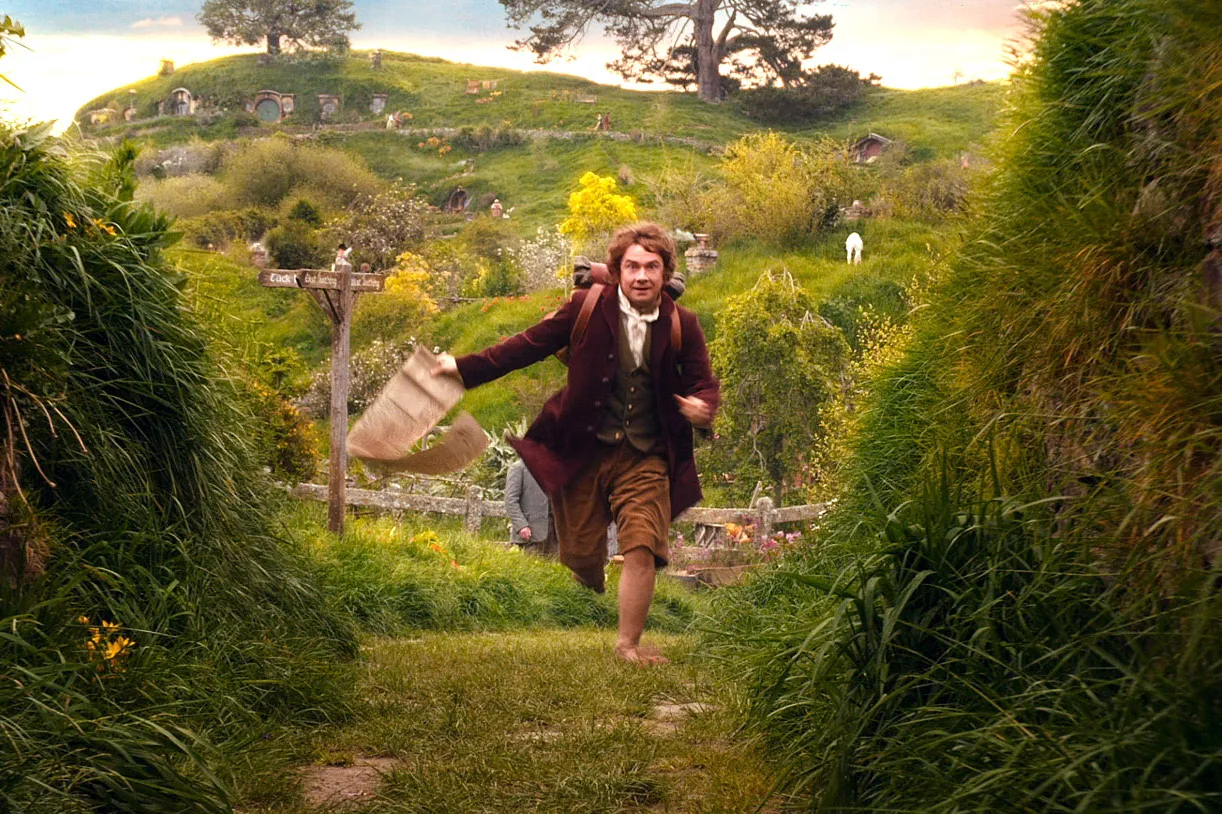Could you create a short story about an unexpected adventure that began in the Shire? In the peaceful hills of the Shire, a young hobbit named Ferno was known for his love of maps and exploring. One fine morning, as he was tidying up his hobbit hole, he stumbled upon an old, dusty map hidden beneath the floorboards. The map showed a forgotten path leading to an ancient treasure buried deep within the Misty Mountains. Advised by the wise Gandalf, Ferno set off on an unexpected adventure, braving rivers, forests, and mysterious creatures to uncover the long-lost treasure. Little did he know, this journey would change the course of his quiet life forever, bringing him face to face with dragons, hidden cities, and the legendary sword, the Dawnbreaker. 